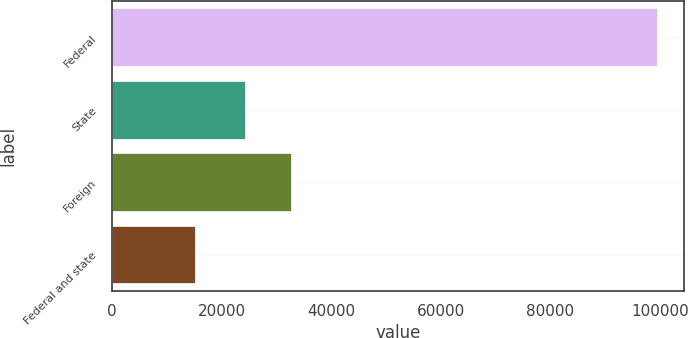Convert chart to OTSL. <chart><loc_0><loc_0><loc_500><loc_500><bar_chart><fcel>Federal<fcel>State<fcel>Foreign<fcel>Federal and state<nl><fcel>99354<fcel>24339<fcel>32755.6<fcel>15188<nl></chart> 